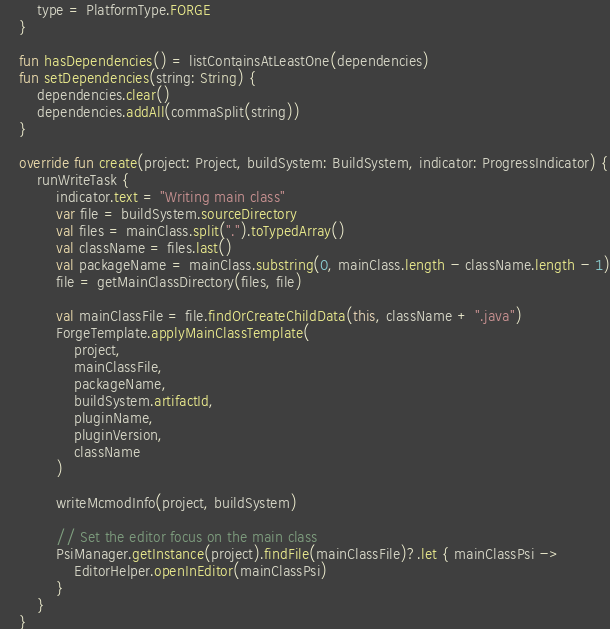<code> <loc_0><loc_0><loc_500><loc_500><_Kotlin_>        type = PlatformType.FORGE
    }

    fun hasDependencies() = listContainsAtLeastOne(dependencies)
    fun setDependencies(string: String) {
        dependencies.clear()
        dependencies.addAll(commaSplit(string))
    }

    override fun create(project: Project, buildSystem: BuildSystem, indicator: ProgressIndicator) {
        runWriteTask {
            indicator.text = "Writing main class"
            var file = buildSystem.sourceDirectory
            val files = mainClass.split(".").toTypedArray()
            val className = files.last()
            val packageName = mainClass.substring(0, mainClass.length - className.length - 1)
            file = getMainClassDirectory(files, file)

            val mainClassFile = file.findOrCreateChildData(this, className + ".java")
            ForgeTemplate.applyMainClassTemplate(
                project,
                mainClassFile,
                packageName,
                buildSystem.artifactId,
                pluginName,
                pluginVersion,
                className
            )

            writeMcmodInfo(project, buildSystem)

            // Set the editor focus on the main class
            PsiManager.getInstance(project).findFile(mainClassFile)?.let { mainClassPsi ->
                EditorHelper.openInEditor(mainClassPsi)
            }
        }
    }
</code> 